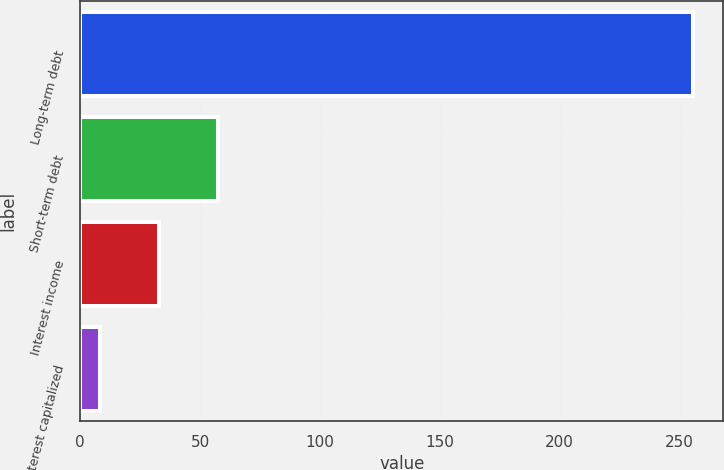<chart> <loc_0><loc_0><loc_500><loc_500><bar_chart><fcel>Long-term debt<fcel>Short-term debt<fcel>Interest income<fcel>Interest capitalized<nl><fcel>255.4<fcel>57.56<fcel>32.83<fcel>8.1<nl></chart> 